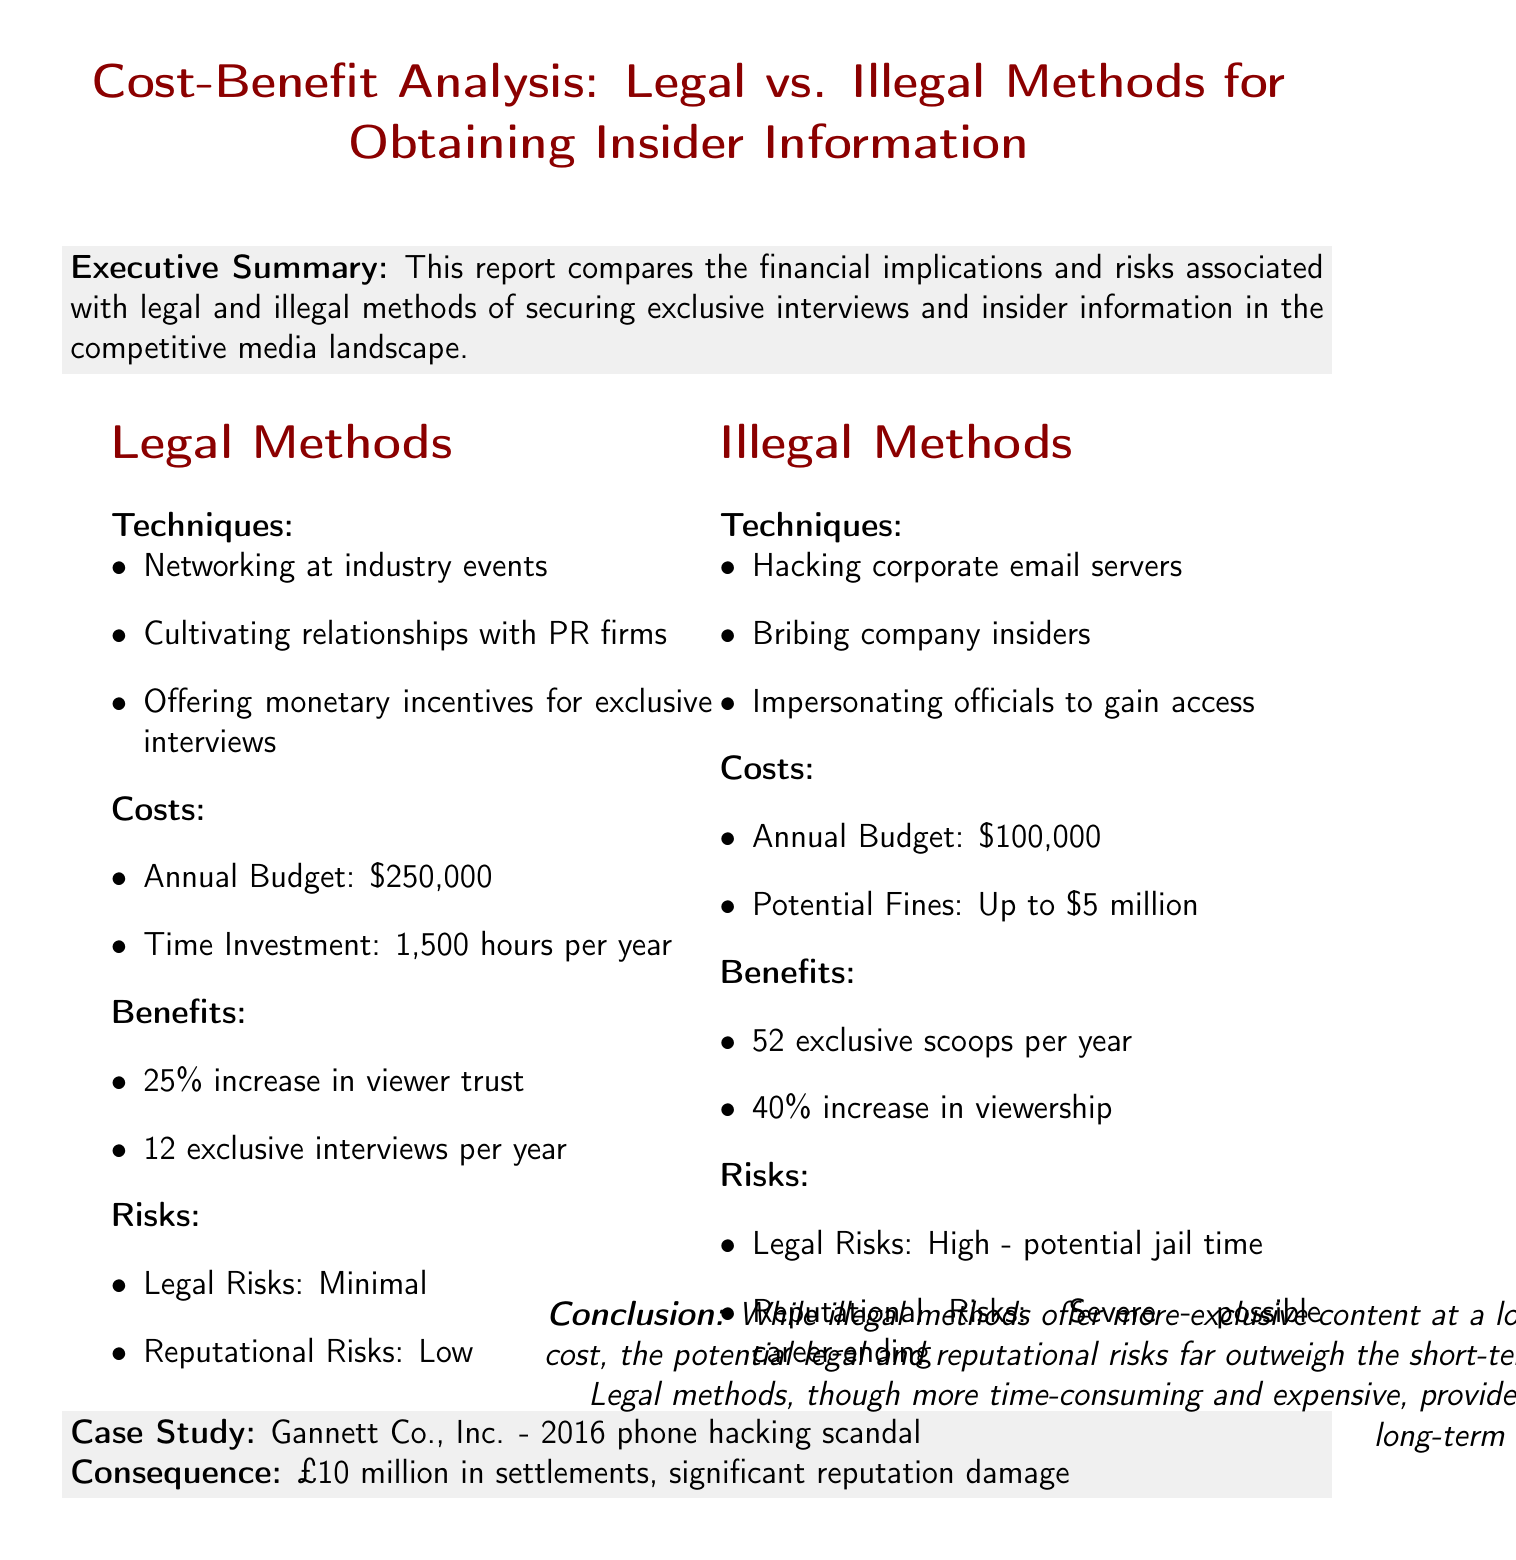what is the report title? The title of the report is stated at the beginning of the document.
Answer: Cost-Benefit Analysis: Legal vs. Illegal Methods for Obtaining Insider Information what is the annual budget for legal methods? The annual budget for legal methods is given in the costs section under legal methods.
Answer: $250,000 how many exclusive interviews are obtained legally per year? The number of exclusive interviews obtained legally is stated in the benefits section under legal methods.
Answer: 12 per year what is the potential fine for illegal methods? The potential fines for illegal methods are mentioned in the costs section under illegal methods.
Answer: Up to $5 million what is the increase in viewership from illegal methods? The increase in viewership from illegal methods is noted in the benefits section under illegal methods.
Answer: 40% increase what was the consequence of the 2016 phone hacking scandal? The consequence of the scandal is reported in the case study section detailing its impact.
Answer: £10 million in settlements, significant reputation damage which method has a minimal legal risk? The level of legal risk for each method is specified in their respective risks sections.
Answer: Legal Methods which method provides more exclusive scoops per year? The number of exclusive scoops per year is compared in the benefits sections of both methods.
Answer: Illegal Methods what does the conclusion emphasize about long-term advantages? The conclusion discusses the long-term advantages of legal methods compared to illegal methods.
Answer: Sustainable long-term advantages 